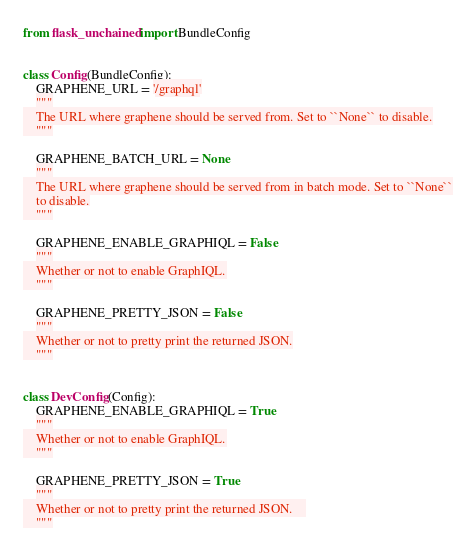Convert code to text. <code><loc_0><loc_0><loc_500><loc_500><_Python_>from flask_unchained import BundleConfig


class Config(BundleConfig):
    GRAPHENE_URL = '/graphql'
    """
    The URL where graphene should be served from. Set to ``None`` to disable.
    """

    GRAPHENE_BATCH_URL = None
    """
    The URL where graphene should be served from in batch mode. Set to ``None``
    to disable.
    """

    GRAPHENE_ENABLE_GRAPHIQL = False
    """
    Whether or not to enable GraphIQL.
    """

    GRAPHENE_PRETTY_JSON = False
    """
    Whether or not to pretty print the returned JSON.
    """


class DevConfig(Config):
    GRAPHENE_ENABLE_GRAPHIQL = True
    """
    Whether or not to enable GraphIQL.
    """

    GRAPHENE_PRETTY_JSON = True
    """
    Whether or not to pretty print the returned JSON.    
    """
</code> 